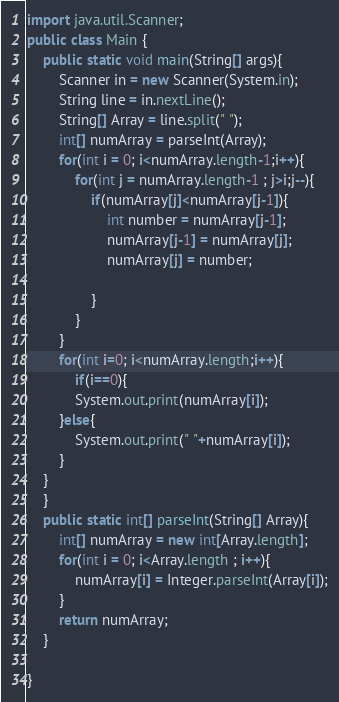<code> <loc_0><loc_0><loc_500><loc_500><_Java_>import java.util.Scanner; 
public class Main {
	public static void main(String[] args){
		Scanner in = new Scanner(System.in);
		String line = in.nextLine();
		String[] Array = line.split(" ");
		int[] numArray = parseInt(Array);
		for(int i = 0; i<numArray.length-1;i++){
			for(int j = numArray.length-1 ; j>i;j--){
				if(numArray[j]<numArray[j-1]){
					int number = numArray[j-1];
					numArray[j-1] = numArray[j];
					numArray[j] = number;

				}
			}
		}
		for(int i=0; i<numArray.length;i++){
			if(i==0){
			System.out.print(numArray[i]);
		}else{
			System.out.print(" "+numArray[i]);
		}
	}
	}
	public static int[] parseInt(String[] Array){
		int[] numArray = new int[Array.length];
		for(int i = 0; i<Array.length ; i++){
			numArray[i] = Integer.parseInt(Array[i]);
		}
		return numArray; 
	} 

}</code> 